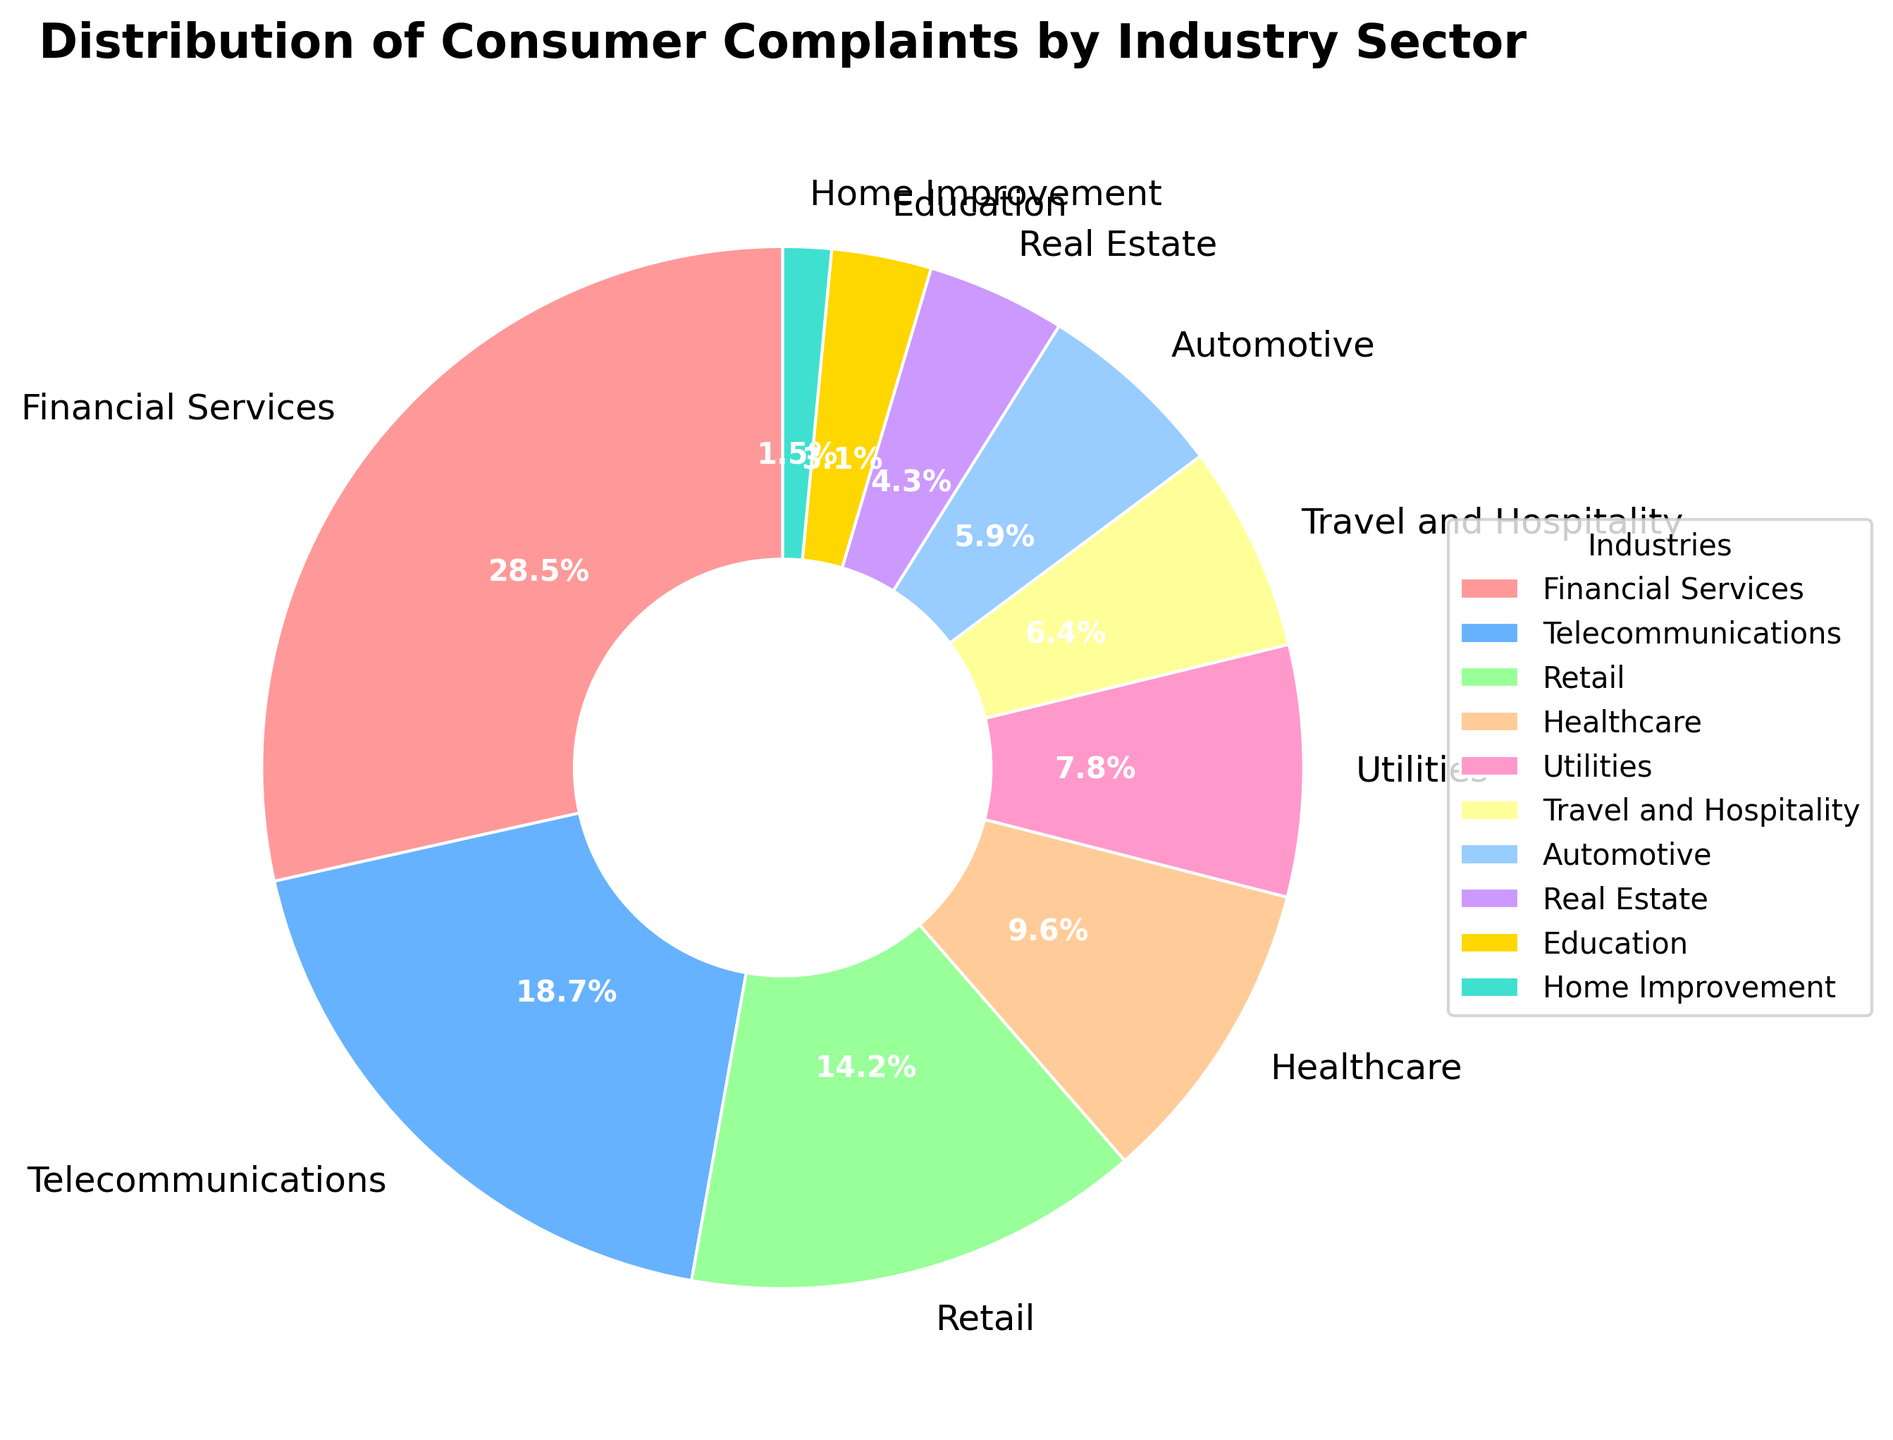What is the largest industry sector by percentage? The largest percentage shown in the pie chart is labeled as Financial Services with 28.5%.
Answer: Financial Services Which industry sector has the second highest percentage of consumer complaints? The second highest percentage shown in the pie chart is labeled as Telecommunications with 18.7%.
Answer: Telecommunications How many industry sectors have a percentage higher than 10%? The industry sectors with percentages higher than 10% are Financial Services (28.5%), Telecommunications (18.7%), and Retail (14.2%). Count these sectors to get the answer.
Answer: 3 What is the combined percentage of the Utilities and Automotive sectors? The percentage of Utilities is 7.8% and the percentage of Automotive is 5.9%. Add these two percentages: 7.8% + 5.9% = 13.7%.
Answer: 13.7% Which sector has the lowest percentage of consumer complaints and what is that percentage? The lowest percentage shown in the pie chart is labeled as Home Improvement with 1.5%.
Answer: Home Improvement, 1.5% Compare the total percentage of Healthcare and Real Estate sectors to that of the Telecommunications sector. Which is higher? The combined percentage of Healthcare and Real Estate is 9.6% + 4.3% = 13.9%. The percentage of Telecommunications is 18.7%. Hence, Telecommunications is higher.
Answer: Telecommunications Is the percentage of Retail sector complaints more or less than half of the Financial Services sector complaints? The percentage of Retail is 14.2%, and half of the Financial Services percentage is 28.5%/2 = 14.25%. Since 14.2% is less than 14.25%, Retail is less.
Answer: Less By how much does the percentage of complaints in Travel and Hospitality exceed that of Home Improvement? The percentage for Travel and Hospitality is 6.4% and for Home Improvement it is 1.5%. Subtract these percentages: 6.4% - 1.5% = 4.9%.
Answer: 4.9% Which sector, Real Estate or Education, has a higher percentage of consumer complaints? The percentage for Real Estate is 4.3% and the percentage for Education is 3.1%. Real Estate is higher.
Answer: Real Estate What is the average percentage of complaints for Travel and Hospitality, Automotive, and Real Estate sectors combined? The percentages are Travel and Hospitality (6.4%), Automotive (5.9%), and Real Estate (4.3%). Sum these percentages: 6.4% + 5.9% + 4.3% = 16.6%. Divide by the number of sectors: 16.6% / 3 ≈ 5.53%.
Answer: 5.53% 